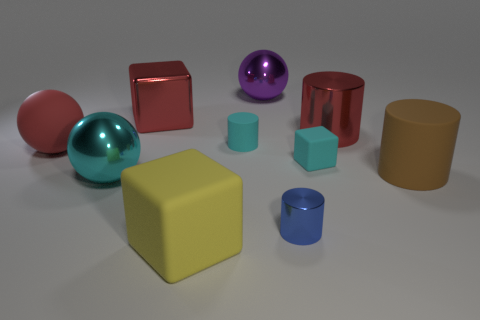Subtract all cylinders. How many objects are left? 6 Subtract 1 cyan cylinders. How many objects are left? 9 Subtract all tiny matte cylinders. Subtract all brown matte cylinders. How many objects are left? 8 Add 1 large cylinders. How many large cylinders are left? 3 Add 4 small yellow matte spheres. How many small yellow matte spheres exist? 4 